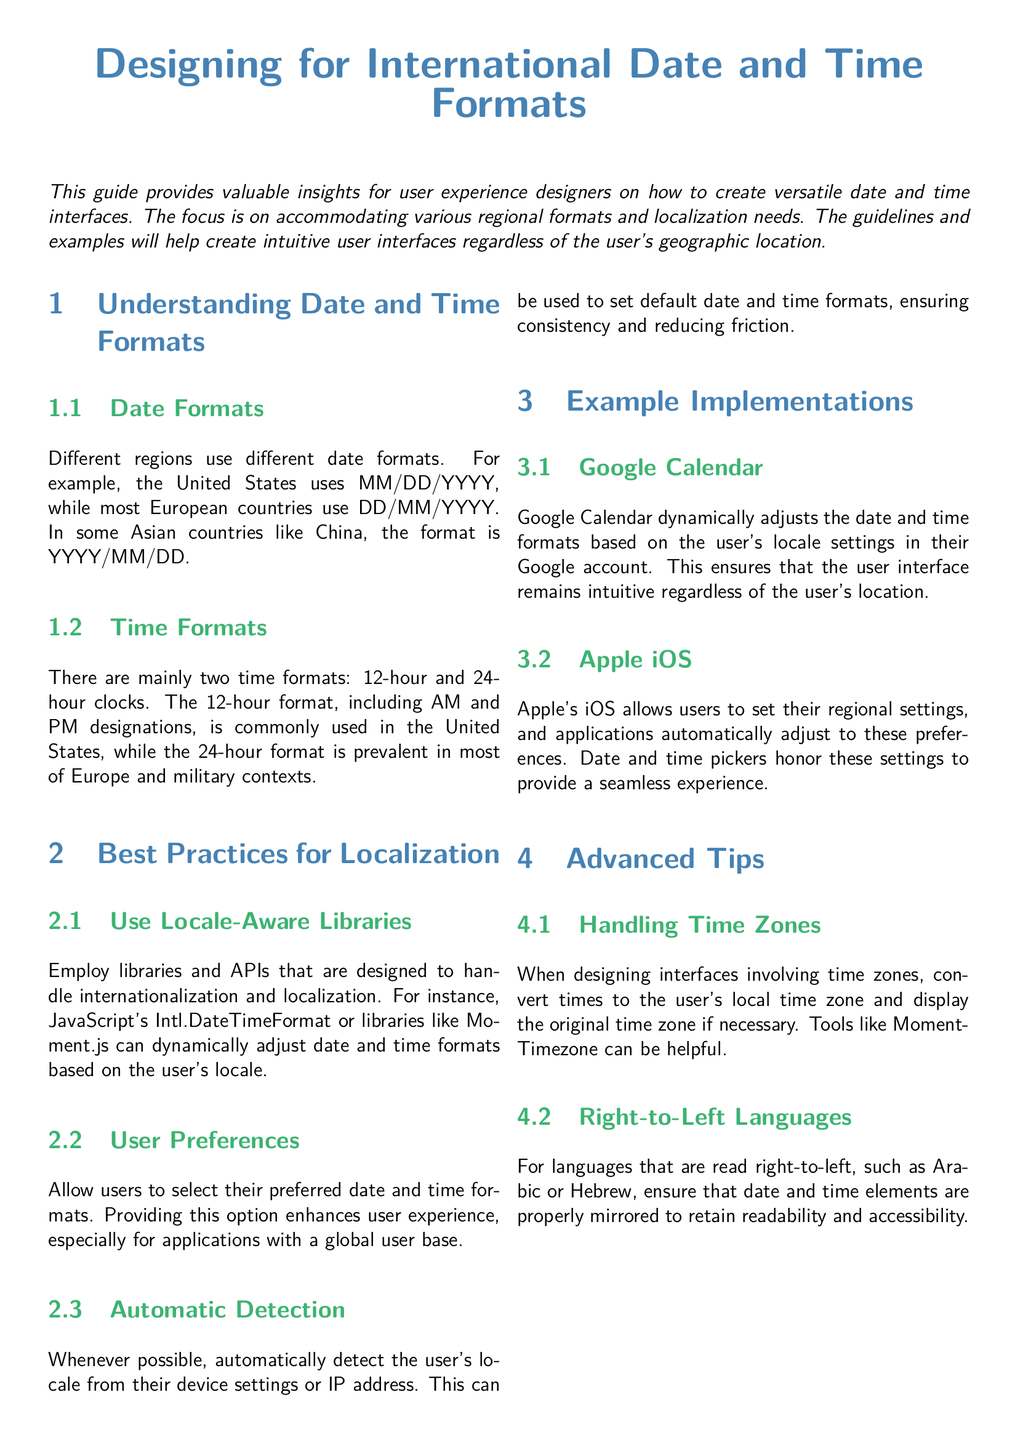What is the primary focus of this guide? The guide focuses on creating versatile date and time interfaces that accommodate various regional formats and localization needs.
Answer: versatile date and time interfaces Which date format does the United States use? The document states the date format used in the United States is MM/DD/YYYY.
Answer: MM/DD/YYYY What are the two main time formats mentioned? The document lists the two main time formats as 12-hour and 24-hour clocks.
Answer: 12-hour and 24-hour clocks What library is mentioned for handling internationalization? The guide mentions JavaScript's Intl.DateTimeFormat as a library for handling internationalization.
Answer: Intl.DateTimeFormat How does Google Calendar adjust date and time formats? The document explains that Google Calendar adjusts formats based on the user's locale settings.
Answer: user's locale settings What is one advanced tip provided for handling time zones? The document suggests converting times to the user's local time zone as an advanced tip for handling time zones.
Answer: convert to user's local time zone What is one method for respecting user preferences? The guide suggests allowing users to select their preferred date and time formats.
Answer: select preferred formats What should designers consider for right-to-left languages? The document indicates that designers should ensure date and time elements are properly mirrored for right-to-left languages.
Answer: properly mirrored What is emphasized as important in the conclusion? The conclusion emphasizes understanding regional variations for designing interfaces.
Answer: understanding regional variations 